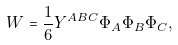Convert formula to latex. <formula><loc_0><loc_0><loc_500><loc_500>W = \frac { 1 } { 6 } Y ^ { A B C } \Phi _ { A } \Phi _ { B } \Phi _ { C } ,</formula> 